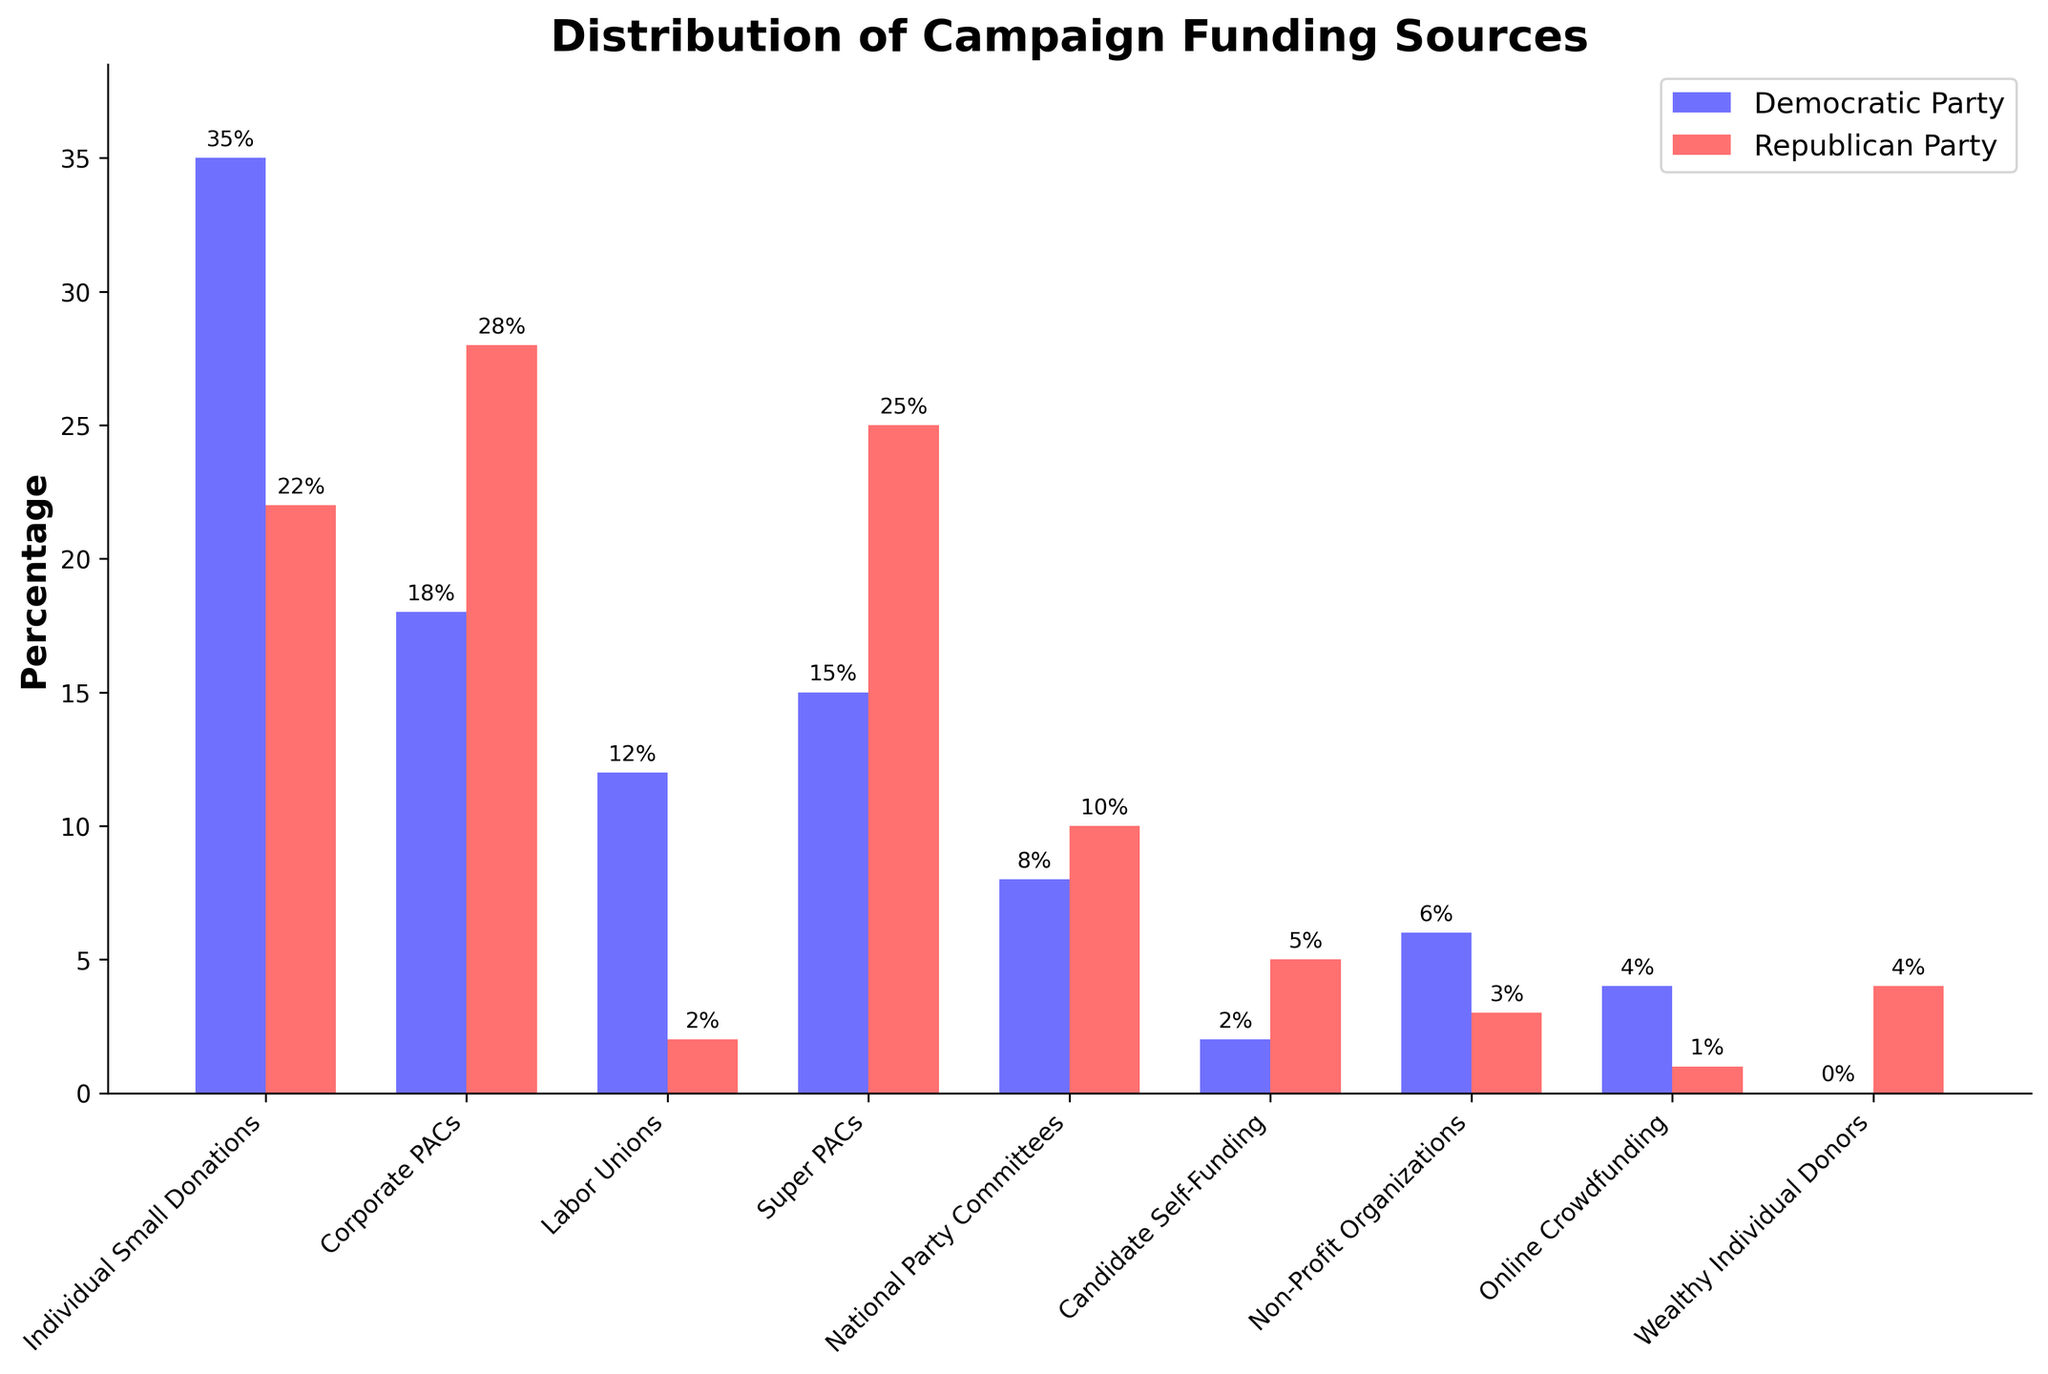Which funding source has the highest percentage for the Democratic Party? By observing the heights of the blue bars representing the Democrats, the Individual Small Donations bar has the highest value.
Answer: Individual Small Donations Which funding source contributes more to the Republican Party, Corporate PACs or Super PACs? By comparing the heights of the red bars for Corporate PACs and Super PACs, the Super PACs bar is higher.
Answer: Super PACs What is the total percentage of funding for the Democratic Party from Individual Small Donations and Labor Unions combined? The Individual Small Donations bar for the Democratic Party is 35%, and the Labor Unions bar is 12%. Combining them: 35 + 12 = 47.
Answer: 47% Which party receives more funding from National Party Committees? Comparing the heights of the blue and red bars for National Party Committees, the Republican Party's red bar is slightly higher.
Answer: Republican Party What is the percentage difference in Corporate PACs funding between the Democratic and Republican parties? The Corporate PACs bar for the Democratic Party is at 18%, and the same for the Republican Party is at 28%. The difference is: 28 - 18 = 10%.
Answer: 10% Which funding source has the lowest percentage for both parties combined? Observing the combined height of both blue and red bars for all funding sources, Wealthy Individual Donors has the lowest total (0% Democratic + 4% Republican).
Answer: Wealthy Individual Donors By which percentage do Labor Unions contribute more to the Democratic Party than the Republican Party? The Labor Unions bar for the Democratic Party is 12%, while for the Republican Party it is 2%. The difference is 12 - 2 = 10%.
Answer: 10% What funding sources contribute equally to both parties? By observing the bars, there are no sources where both parties receive an identical percentage.
Answer: None How many sources contribute more than 20% to the Republican Party? By counting the red bars with a height more than 20%, both Corporate PACs (28%) and Super PACs (25%) qualify. Thus, there are 2 sources.
Answer: 2 What is the average percentage of funding from Online Crowdfunding for both parties? The Online Crowdfunding bar for the Democratic Party is 4%, and for the Republican Party, it is 1%. The average is (4 + 1) / 2 = 2.5%.
Answer: 2.5% 